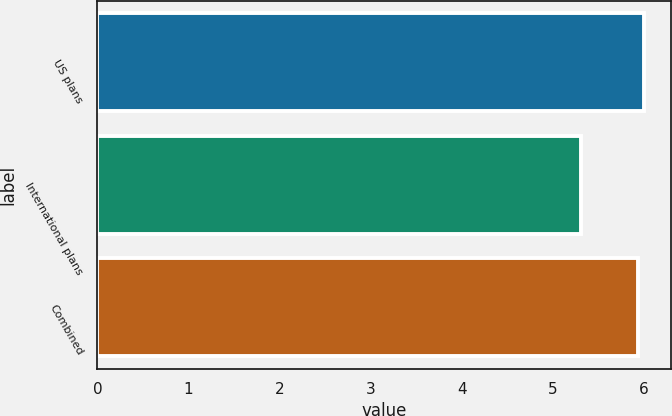<chart> <loc_0><loc_0><loc_500><loc_500><bar_chart><fcel>US plans<fcel>International plans<fcel>Combined<nl><fcel>6<fcel>5.31<fcel>5.93<nl></chart> 